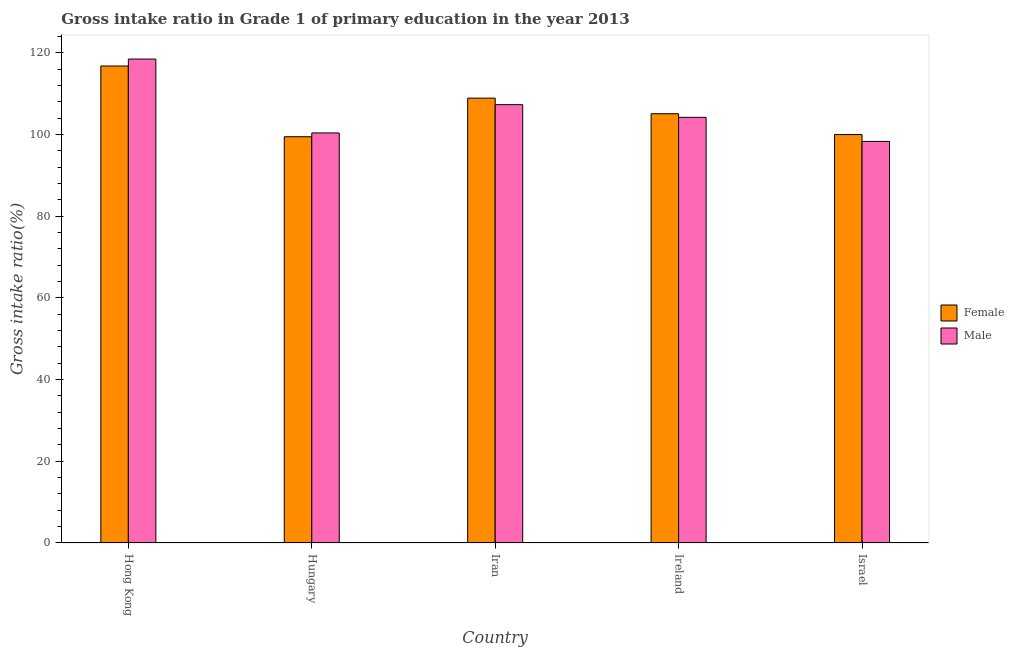How many groups of bars are there?
Offer a very short reply. 5. What is the label of the 2nd group of bars from the left?
Offer a very short reply. Hungary. In how many cases, is the number of bars for a given country not equal to the number of legend labels?
Keep it short and to the point. 0. What is the gross intake ratio(female) in Hungary?
Your answer should be very brief. 99.44. Across all countries, what is the maximum gross intake ratio(female)?
Give a very brief answer. 116.74. Across all countries, what is the minimum gross intake ratio(male)?
Ensure brevity in your answer.  98.29. In which country was the gross intake ratio(female) maximum?
Provide a succinct answer. Hong Kong. What is the total gross intake ratio(female) in the graph?
Provide a succinct answer. 530.11. What is the difference between the gross intake ratio(male) in Iran and that in Israel?
Provide a succinct answer. 8.99. What is the difference between the gross intake ratio(male) in Hungary and the gross intake ratio(female) in Hong Kong?
Provide a succinct answer. -16.38. What is the average gross intake ratio(female) per country?
Give a very brief answer. 106.02. What is the difference between the gross intake ratio(male) and gross intake ratio(female) in Ireland?
Provide a succinct answer. -0.89. What is the ratio of the gross intake ratio(male) in Hungary to that in Ireland?
Provide a short and direct response. 0.96. What is the difference between the highest and the second highest gross intake ratio(male)?
Your answer should be compact. 11.16. What is the difference between the highest and the lowest gross intake ratio(male)?
Make the answer very short. 20.15. In how many countries, is the gross intake ratio(female) greater than the average gross intake ratio(female) taken over all countries?
Offer a very short reply. 2. What does the 2nd bar from the right in Hong Kong represents?
Provide a short and direct response. Female. How many bars are there?
Keep it short and to the point. 10. Does the graph contain grids?
Give a very brief answer. No. How are the legend labels stacked?
Provide a short and direct response. Vertical. What is the title of the graph?
Offer a terse response. Gross intake ratio in Grade 1 of primary education in the year 2013. What is the label or title of the X-axis?
Your answer should be very brief. Country. What is the label or title of the Y-axis?
Offer a terse response. Gross intake ratio(%). What is the Gross intake ratio(%) in Female in Hong Kong?
Offer a terse response. 116.74. What is the Gross intake ratio(%) of Male in Hong Kong?
Your response must be concise. 118.45. What is the Gross intake ratio(%) in Female in Hungary?
Keep it short and to the point. 99.44. What is the Gross intake ratio(%) of Male in Hungary?
Make the answer very short. 100.36. What is the Gross intake ratio(%) in Female in Iran?
Offer a very short reply. 108.89. What is the Gross intake ratio(%) in Male in Iran?
Provide a short and direct response. 107.29. What is the Gross intake ratio(%) in Female in Ireland?
Give a very brief answer. 105.07. What is the Gross intake ratio(%) in Male in Ireland?
Your response must be concise. 104.18. What is the Gross intake ratio(%) of Female in Israel?
Give a very brief answer. 99.97. What is the Gross intake ratio(%) in Male in Israel?
Offer a terse response. 98.29. Across all countries, what is the maximum Gross intake ratio(%) in Female?
Your response must be concise. 116.74. Across all countries, what is the maximum Gross intake ratio(%) in Male?
Make the answer very short. 118.45. Across all countries, what is the minimum Gross intake ratio(%) in Female?
Your answer should be compact. 99.44. Across all countries, what is the minimum Gross intake ratio(%) in Male?
Your answer should be very brief. 98.29. What is the total Gross intake ratio(%) in Female in the graph?
Provide a succinct answer. 530.11. What is the total Gross intake ratio(%) of Male in the graph?
Your answer should be compact. 528.57. What is the difference between the Gross intake ratio(%) of Female in Hong Kong and that in Hungary?
Provide a short and direct response. 17.31. What is the difference between the Gross intake ratio(%) in Male in Hong Kong and that in Hungary?
Offer a very short reply. 18.08. What is the difference between the Gross intake ratio(%) in Female in Hong Kong and that in Iran?
Provide a succinct answer. 7.86. What is the difference between the Gross intake ratio(%) in Male in Hong Kong and that in Iran?
Provide a succinct answer. 11.16. What is the difference between the Gross intake ratio(%) in Female in Hong Kong and that in Ireland?
Offer a terse response. 11.67. What is the difference between the Gross intake ratio(%) in Male in Hong Kong and that in Ireland?
Offer a terse response. 14.27. What is the difference between the Gross intake ratio(%) of Female in Hong Kong and that in Israel?
Give a very brief answer. 16.77. What is the difference between the Gross intake ratio(%) in Male in Hong Kong and that in Israel?
Provide a short and direct response. 20.15. What is the difference between the Gross intake ratio(%) of Female in Hungary and that in Iran?
Your response must be concise. -9.45. What is the difference between the Gross intake ratio(%) of Male in Hungary and that in Iran?
Your response must be concise. -6.92. What is the difference between the Gross intake ratio(%) of Female in Hungary and that in Ireland?
Provide a short and direct response. -5.63. What is the difference between the Gross intake ratio(%) in Male in Hungary and that in Ireland?
Your response must be concise. -3.82. What is the difference between the Gross intake ratio(%) of Female in Hungary and that in Israel?
Provide a short and direct response. -0.53. What is the difference between the Gross intake ratio(%) in Male in Hungary and that in Israel?
Keep it short and to the point. 2.07. What is the difference between the Gross intake ratio(%) in Female in Iran and that in Ireland?
Offer a terse response. 3.82. What is the difference between the Gross intake ratio(%) in Male in Iran and that in Ireland?
Offer a terse response. 3.11. What is the difference between the Gross intake ratio(%) in Female in Iran and that in Israel?
Your answer should be very brief. 8.92. What is the difference between the Gross intake ratio(%) in Male in Iran and that in Israel?
Ensure brevity in your answer.  8.99. What is the difference between the Gross intake ratio(%) of Female in Ireland and that in Israel?
Make the answer very short. 5.1. What is the difference between the Gross intake ratio(%) of Male in Ireland and that in Israel?
Ensure brevity in your answer.  5.89. What is the difference between the Gross intake ratio(%) in Female in Hong Kong and the Gross intake ratio(%) in Male in Hungary?
Your answer should be compact. 16.38. What is the difference between the Gross intake ratio(%) of Female in Hong Kong and the Gross intake ratio(%) of Male in Iran?
Provide a succinct answer. 9.46. What is the difference between the Gross intake ratio(%) in Female in Hong Kong and the Gross intake ratio(%) in Male in Ireland?
Give a very brief answer. 12.56. What is the difference between the Gross intake ratio(%) of Female in Hong Kong and the Gross intake ratio(%) of Male in Israel?
Keep it short and to the point. 18.45. What is the difference between the Gross intake ratio(%) in Female in Hungary and the Gross intake ratio(%) in Male in Iran?
Your answer should be very brief. -7.85. What is the difference between the Gross intake ratio(%) of Female in Hungary and the Gross intake ratio(%) of Male in Ireland?
Make the answer very short. -4.74. What is the difference between the Gross intake ratio(%) in Female in Hungary and the Gross intake ratio(%) in Male in Israel?
Offer a terse response. 1.14. What is the difference between the Gross intake ratio(%) of Female in Iran and the Gross intake ratio(%) of Male in Ireland?
Offer a very short reply. 4.71. What is the difference between the Gross intake ratio(%) in Female in Iran and the Gross intake ratio(%) in Male in Israel?
Ensure brevity in your answer.  10.59. What is the difference between the Gross intake ratio(%) of Female in Ireland and the Gross intake ratio(%) of Male in Israel?
Give a very brief answer. 6.78. What is the average Gross intake ratio(%) in Female per country?
Make the answer very short. 106.02. What is the average Gross intake ratio(%) of Male per country?
Keep it short and to the point. 105.71. What is the difference between the Gross intake ratio(%) in Female and Gross intake ratio(%) in Male in Hong Kong?
Keep it short and to the point. -1.7. What is the difference between the Gross intake ratio(%) in Female and Gross intake ratio(%) in Male in Hungary?
Offer a terse response. -0.93. What is the difference between the Gross intake ratio(%) of Female and Gross intake ratio(%) of Male in Iran?
Make the answer very short. 1.6. What is the difference between the Gross intake ratio(%) in Female and Gross intake ratio(%) in Male in Ireland?
Your answer should be compact. 0.89. What is the difference between the Gross intake ratio(%) in Female and Gross intake ratio(%) in Male in Israel?
Keep it short and to the point. 1.68. What is the ratio of the Gross intake ratio(%) of Female in Hong Kong to that in Hungary?
Offer a terse response. 1.17. What is the ratio of the Gross intake ratio(%) of Male in Hong Kong to that in Hungary?
Offer a terse response. 1.18. What is the ratio of the Gross intake ratio(%) in Female in Hong Kong to that in Iran?
Give a very brief answer. 1.07. What is the ratio of the Gross intake ratio(%) in Male in Hong Kong to that in Iran?
Your answer should be compact. 1.1. What is the ratio of the Gross intake ratio(%) of Male in Hong Kong to that in Ireland?
Offer a terse response. 1.14. What is the ratio of the Gross intake ratio(%) in Female in Hong Kong to that in Israel?
Keep it short and to the point. 1.17. What is the ratio of the Gross intake ratio(%) in Male in Hong Kong to that in Israel?
Offer a terse response. 1.21. What is the ratio of the Gross intake ratio(%) in Female in Hungary to that in Iran?
Offer a terse response. 0.91. What is the ratio of the Gross intake ratio(%) of Male in Hungary to that in Iran?
Provide a succinct answer. 0.94. What is the ratio of the Gross intake ratio(%) of Female in Hungary to that in Ireland?
Keep it short and to the point. 0.95. What is the ratio of the Gross intake ratio(%) of Male in Hungary to that in Ireland?
Your response must be concise. 0.96. What is the ratio of the Gross intake ratio(%) in Male in Hungary to that in Israel?
Provide a short and direct response. 1.02. What is the ratio of the Gross intake ratio(%) in Female in Iran to that in Ireland?
Offer a very short reply. 1.04. What is the ratio of the Gross intake ratio(%) in Male in Iran to that in Ireland?
Give a very brief answer. 1.03. What is the ratio of the Gross intake ratio(%) of Female in Iran to that in Israel?
Your answer should be very brief. 1.09. What is the ratio of the Gross intake ratio(%) of Male in Iran to that in Israel?
Your response must be concise. 1.09. What is the ratio of the Gross intake ratio(%) in Female in Ireland to that in Israel?
Give a very brief answer. 1.05. What is the ratio of the Gross intake ratio(%) in Male in Ireland to that in Israel?
Your response must be concise. 1.06. What is the difference between the highest and the second highest Gross intake ratio(%) in Female?
Provide a succinct answer. 7.86. What is the difference between the highest and the second highest Gross intake ratio(%) in Male?
Your response must be concise. 11.16. What is the difference between the highest and the lowest Gross intake ratio(%) in Female?
Your answer should be very brief. 17.31. What is the difference between the highest and the lowest Gross intake ratio(%) of Male?
Keep it short and to the point. 20.15. 